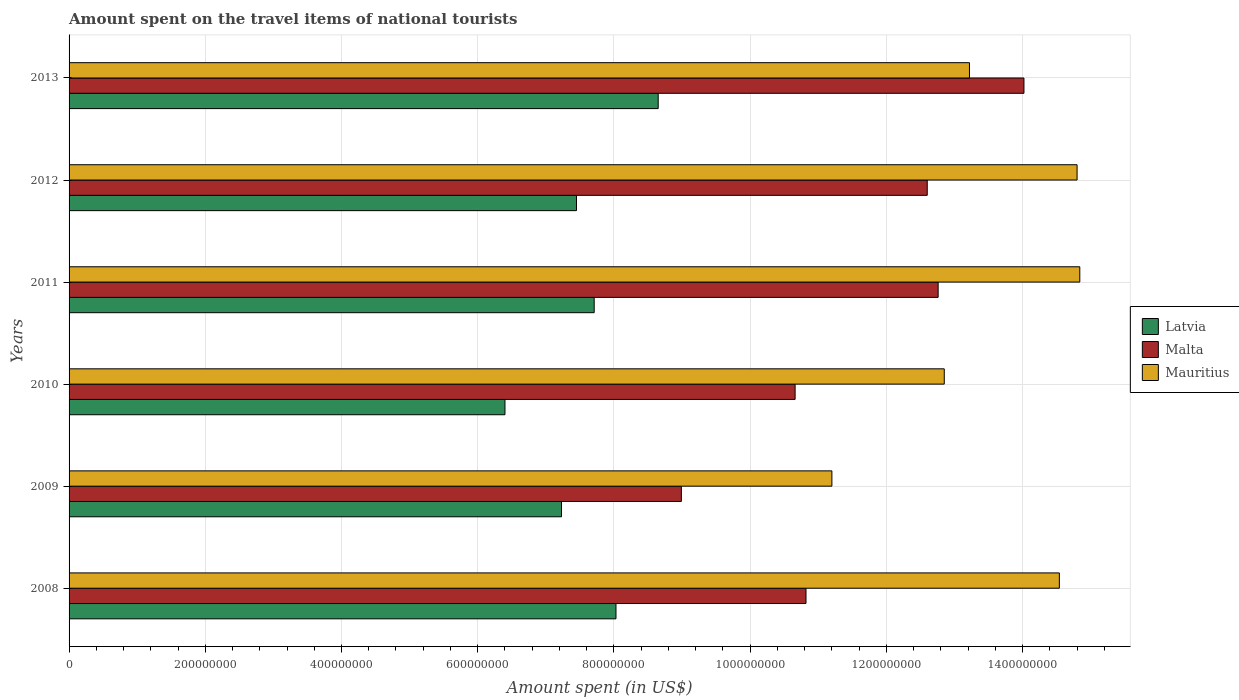How many bars are there on the 2nd tick from the top?
Your response must be concise. 3. What is the label of the 5th group of bars from the top?
Your answer should be very brief. 2009. In how many cases, is the number of bars for a given year not equal to the number of legend labels?
Ensure brevity in your answer.  0. What is the amount spent on the travel items of national tourists in Latvia in 2008?
Your response must be concise. 8.03e+08. Across all years, what is the maximum amount spent on the travel items of national tourists in Malta?
Your answer should be compact. 1.40e+09. Across all years, what is the minimum amount spent on the travel items of national tourists in Malta?
Offer a very short reply. 8.99e+08. In which year was the amount spent on the travel items of national tourists in Latvia maximum?
Your answer should be very brief. 2013. In which year was the amount spent on the travel items of national tourists in Mauritius minimum?
Provide a short and direct response. 2009. What is the total amount spent on the travel items of national tourists in Latvia in the graph?
Offer a very short reply. 4.55e+09. What is the difference between the amount spent on the travel items of national tourists in Malta in 2008 and that in 2009?
Offer a terse response. 1.83e+08. What is the difference between the amount spent on the travel items of national tourists in Latvia in 2009 and the amount spent on the travel items of national tourists in Malta in 2008?
Offer a very short reply. -3.59e+08. What is the average amount spent on the travel items of national tourists in Mauritius per year?
Keep it short and to the point. 1.36e+09. In the year 2010, what is the difference between the amount spent on the travel items of national tourists in Mauritius and amount spent on the travel items of national tourists in Malta?
Keep it short and to the point. 2.19e+08. What is the ratio of the amount spent on the travel items of national tourists in Malta in 2008 to that in 2009?
Your answer should be compact. 1.2. Is the difference between the amount spent on the travel items of national tourists in Mauritius in 2008 and 2009 greater than the difference between the amount spent on the travel items of national tourists in Malta in 2008 and 2009?
Offer a terse response. Yes. What is the difference between the highest and the second highest amount spent on the travel items of national tourists in Malta?
Offer a terse response. 1.26e+08. What is the difference between the highest and the lowest amount spent on the travel items of national tourists in Mauritius?
Keep it short and to the point. 3.64e+08. In how many years, is the amount spent on the travel items of national tourists in Malta greater than the average amount spent on the travel items of national tourists in Malta taken over all years?
Provide a succinct answer. 3. What does the 2nd bar from the top in 2009 represents?
Give a very brief answer. Malta. What does the 3rd bar from the bottom in 2008 represents?
Make the answer very short. Mauritius. Is it the case that in every year, the sum of the amount spent on the travel items of national tourists in Malta and amount spent on the travel items of national tourists in Latvia is greater than the amount spent on the travel items of national tourists in Mauritius?
Give a very brief answer. Yes. How many bars are there?
Provide a succinct answer. 18. Are all the bars in the graph horizontal?
Your answer should be compact. Yes. How many years are there in the graph?
Give a very brief answer. 6. Are the values on the major ticks of X-axis written in scientific E-notation?
Give a very brief answer. No. Where does the legend appear in the graph?
Your response must be concise. Center right. How are the legend labels stacked?
Provide a succinct answer. Vertical. What is the title of the graph?
Your answer should be compact. Amount spent on the travel items of national tourists. What is the label or title of the X-axis?
Offer a terse response. Amount spent (in US$). What is the Amount spent (in US$) of Latvia in 2008?
Provide a succinct answer. 8.03e+08. What is the Amount spent (in US$) of Malta in 2008?
Give a very brief answer. 1.08e+09. What is the Amount spent (in US$) in Mauritius in 2008?
Provide a succinct answer. 1.45e+09. What is the Amount spent (in US$) in Latvia in 2009?
Offer a terse response. 7.23e+08. What is the Amount spent (in US$) of Malta in 2009?
Make the answer very short. 8.99e+08. What is the Amount spent (in US$) of Mauritius in 2009?
Offer a terse response. 1.12e+09. What is the Amount spent (in US$) in Latvia in 2010?
Your answer should be compact. 6.40e+08. What is the Amount spent (in US$) in Malta in 2010?
Your response must be concise. 1.07e+09. What is the Amount spent (in US$) in Mauritius in 2010?
Your response must be concise. 1.28e+09. What is the Amount spent (in US$) of Latvia in 2011?
Ensure brevity in your answer.  7.71e+08. What is the Amount spent (in US$) of Malta in 2011?
Your answer should be very brief. 1.28e+09. What is the Amount spent (in US$) in Mauritius in 2011?
Your response must be concise. 1.48e+09. What is the Amount spent (in US$) of Latvia in 2012?
Offer a terse response. 7.45e+08. What is the Amount spent (in US$) in Malta in 2012?
Offer a very short reply. 1.26e+09. What is the Amount spent (in US$) in Mauritius in 2012?
Provide a succinct answer. 1.48e+09. What is the Amount spent (in US$) of Latvia in 2013?
Provide a succinct answer. 8.65e+08. What is the Amount spent (in US$) of Malta in 2013?
Make the answer very short. 1.40e+09. What is the Amount spent (in US$) of Mauritius in 2013?
Provide a short and direct response. 1.32e+09. Across all years, what is the maximum Amount spent (in US$) in Latvia?
Make the answer very short. 8.65e+08. Across all years, what is the maximum Amount spent (in US$) in Malta?
Offer a very short reply. 1.40e+09. Across all years, what is the maximum Amount spent (in US$) in Mauritius?
Ensure brevity in your answer.  1.48e+09. Across all years, what is the minimum Amount spent (in US$) of Latvia?
Give a very brief answer. 6.40e+08. Across all years, what is the minimum Amount spent (in US$) of Malta?
Your answer should be very brief. 8.99e+08. Across all years, what is the minimum Amount spent (in US$) of Mauritius?
Provide a short and direct response. 1.12e+09. What is the total Amount spent (in US$) of Latvia in the graph?
Offer a terse response. 4.55e+09. What is the total Amount spent (in US$) of Malta in the graph?
Your answer should be compact. 6.98e+09. What is the total Amount spent (in US$) of Mauritius in the graph?
Make the answer very short. 8.14e+09. What is the difference between the Amount spent (in US$) in Latvia in 2008 and that in 2009?
Keep it short and to the point. 8.00e+07. What is the difference between the Amount spent (in US$) of Malta in 2008 and that in 2009?
Your answer should be very brief. 1.83e+08. What is the difference between the Amount spent (in US$) of Mauritius in 2008 and that in 2009?
Give a very brief answer. 3.34e+08. What is the difference between the Amount spent (in US$) in Latvia in 2008 and that in 2010?
Give a very brief answer. 1.63e+08. What is the difference between the Amount spent (in US$) of Malta in 2008 and that in 2010?
Your response must be concise. 1.60e+07. What is the difference between the Amount spent (in US$) of Mauritius in 2008 and that in 2010?
Give a very brief answer. 1.69e+08. What is the difference between the Amount spent (in US$) of Latvia in 2008 and that in 2011?
Ensure brevity in your answer.  3.20e+07. What is the difference between the Amount spent (in US$) of Malta in 2008 and that in 2011?
Your answer should be compact. -1.94e+08. What is the difference between the Amount spent (in US$) of Mauritius in 2008 and that in 2011?
Give a very brief answer. -3.00e+07. What is the difference between the Amount spent (in US$) of Latvia in 2008 and that in 2012?
Provide a succinct answer. 5.80e+07. What is the difference between the Amount spent (in US$) in Malta in 2008 and that in 2012?
Give a very brief answer. -1.78e+08. What is the difference between the Amount spent (in US$) in Mauritius in 2008 and that in 2012?
Your answer should be very brief. -2.60e+07. What is the difference between the Amount spent (in US$) of Latvia in 2008 and that in 2013?
Provide a succinct answer. -6.20e+07. What is the difference between the Amount spent (in US$) in Malta in 2008 and that in 2013?
Ensure brevity in your answer.  -3.20e+08. What is the difference between the Amount spent (in US$) in Mauritius in 2008 and that in 2013?
Provide a short and direct response. 1.32e+08. What is the difference between the Amount spent (in US$) of Latvia in 2009 and that in 2010?
Offer a terse response. 8.30e+07. What is the difference between the Amount spent (in US$) of Malta in 2009 and that in 2010?
Give a very brief answer. -1.67e+08. What is the difference between the Amount spent (in US$) in Mauritius in 2009 and that in 2010?
Make the answer very short. -1.65e+08. What is the difference between the Amount spent (in US$) in Latvia in 2009 and that in 2011?
Keep it short and to the point. -4.80e+07. What is the difference between the Amount spent (in US$) in Malta in 2009 and that in 2011?
Ensure brevity in your answer.  -3.77e+08. What is the difference between the Amount spent (in US$) in Mauritius in 2009 and that in 2011?
Give a very brief answer. -3.64e+08. What is the difference between the Amount spent (in US$) of Latvia in 2009 and that in 2012?
Your response must be concise. -2.20e+07. What is the difference between the Amount spent (in US$) in Malta in 2009 and that in 2012?
Provide a succinct answer. -3.61e+08. What is the difference between the Amount spent (in US$) in Mauritius in 2009 and that in 2012?
Keep it short and to the point. -3.60e+08. What is the difference between the Amount spent (in US$) in Latvia in 2009 and that in 2013?
Keep it short and to the point. -1.42e+08. What is the difference between the Amount spent (in US$) of Malta in 2009 and that in 2013?
Give a very brief answer. -5.03e+08. What is the difference between the Amount spent (in US$) in Mauritius in 2009 and that in 2013?
Ensure brevity in your answer.  -2.02e+08. What is the difference between the Amount spent (in US$) in Latvia in 2010 and that in 2011?
Give a very brief answer. -1.31e+08. What is the difference between the Amount spent (in US$) of Malta in 2010 and that in 2011?
Give a very brief answer. -2.10e+08. What is the difference between the Amount spent (in US$) of Mauritius in 2010 and that in 2011?
Provide a short and direct response. -1.99e+08. What is the difference between the Amount spent (in US$) of Latvia in 2010 and that in 2012?
Offer a terse response. -1.05e+08. What is the difference between the Amount spent (in US$) in Malta in 2010 and that in 2012?
Give a very brief answer. -1.94e+08. What is the difference between the Amount spent (in US$) of Mauritius in 2010 and that in 2012?
Offer a very short reply. -1.95e+08. What is the difference between the Amount spent (in US$) in Latvia in 2010 and that in 2013?
Offer a terse response. -2.25e+08. What is the difference between the Amount spent (in US$) of Malta in 2010 and that in 2013?
Your answer should be very brief. -3.36e+08. What is the difference between the Amount spent (in US$) of Mauritius in 2010 and that in 2013?
Offer a terse response. -3.70e+07. What is the difference between the Amount spent (in US$) in Latvia in 2011 and that in 2012?
Your answer should be compact. 2.60e+07. What is the difference between the Amount spent (in US$) of Malta in 2011 and that in 2012?
Provide a succinct answer. 1.60e+07. What is the difference between the Amount spent (in US$) of Latvia in 2011 and that in 2013?
Keep it short and to the point. -9.40e+07. What is the difference between the Amount spent (in US$) of Malta in 2011 and that in 2013?
Your answer should be very brief. -1.26e+08. What is the difference between the Amount spent (in US$) of Mauritius in 2011 and that in 2013?
Give a very brief answer. 1.62e+08. What is the difference between the Amount spent (in US$) in Latvia in 2012 and that in 2013?
Give a very brief answer. -1.20e+08. What is the difference between the Amount spent (in US$) in Malta in 2012 and that in 2013?
Provide a short and direct response. -1.42e+08. What is the difference between the Amount spent (in US$) in Mauritius in 2012 and that in 2013?
Make the answer very short. 1.58e+08. What is the difference between the Amount spent (in US$) of Latvia in 2008 and the Amount spent (in US$) of Malta in 2009?
Your answer should be very brief. -9.60e+07. What is the difference between the Amount spent (in US$) in Latvia in 2008 and the Amount spent (in US$) in Mauritius in 2009?
Keep it short and to the point. -3.17e+08. What is the difference between the Amount spent (in US$) of Malta in 2008 and the Amount spent (in US$) of Mauritius in 2009?
Offer a terse response. -3.80e+07. What is the difference between the Amount spent (in US$) in Latvia in 2008 and the Amount spent (in US$) in Malta in 2010?
Your answer should be very brief. -2.63e+08. What is the difference between the Amount spent (in US$) of Latvia in 2008 and the Amount spent (in US$) of Mauritius in 2010?
Your response must be concise. -4.82e+08. What is the difference between the Amount spent (in US$) in Malta in 2008 and the Amount spent (in US$) in Mauritius in 2010?
Keep it short and to the point. -2.03e+08. What is the difference between the Amount spent (in US$) of Latvia in 2008 and the Amount spent (in US$) of Malta in 2011?
Make the answer very short. -4.73e+08. What is the difference between the Amount spent (in US$) in Latvia in 2008 and the Amount spent (in US$) in Mauritius in 2011?
Provide a short and direct response. -6.81e+08. What is the difference between the Amount spent (in US$) in Malta in 2008 and the Amount spent (in US$) in Mauritius in 2011?
Ensure brevity in your answer.  -4.02e+08. What is the difference between the Amount spent (in US$) of Latvia in 2008 and the Amount spent (in US$) of Malta in 2012?
Your response must be concise. -4.57e+08. What is the difference between the Amount spent (in US$) of Latvia in 2008 and the Amount spent (in US$) of Mauritius in 2012?
Ensure brevity in your answer.  -6.77e+08. What is the difference between the Amount spent (in US$) of Malta in 2008 and the Amount spent (in US$) of Mauritius in 2012?
Your response must be concise. -3.98e+08. What is the difference between the Amount spent (in US$) of Latvia in 2008 and the Amount spent (in US$) of Malta in 2013?
Your response must be concise. -5.99e+08. What is the difference between the Amount spent (in US$) in Latvia in 2008 and the Amount spent (in US$) in Mauritius in 2013?
Your response must be concise. -5.19e+08. What is the difference between the Amount spent (in US$) in Malta in 2008 and the Amount spent (in US$) in Mauritius in 2013?
Make the answer very short. -2.40e+08. What is the difference between the Amount spent (in US$) in Latvia in 2009 and the Amount spent (in US$) in Malta in 2010?
Your response must be concise. -3.43e+08. What is the difference between the Amount spent (in US$) of Latvia in 2009 and the Amount spent (in US$) of Mauritius in 2010?
Make the answer very short. -5.62e+08. What is the difference between the Amount spent (in US$) of Malta in 2009 and the Amount spent (in US$) of Mauritius in 2010?
Offer a terse response. -3.86e+08. What is the difference between the Amount spent (in US$) in Latvia in 2009 and the Amount spent (in US$) in Malta in 2011?
Your response must be concise. -5.53e+08. What is the difference between the Amount spent (in US$) in Latvia in 2009 and the Amount spent (in US$) in Mauritius in 2011?
Provide a short and direct response. -7.61e+08. What is the difference between the Amount spent (in US$) of Malta in 2009 and the Amount spent (in US$) of Mauritius in 2011?
Offer a very short reply. -5.85e+08. What is the difference between the Amount spent (in US$) in Latvia in 2009 and the Amount spent (in US$) in Malta in 2012?
Offer a very short reply. -5.37e+08. What is the difference between the Amount spent (in US$) in Latvia in 2009 and the Amount spent (in US$) in Mauritius in 2012?
Ensure brevity in your answer.  -7.57e+08. What is the difference between the Amount spent (in US$) in Malta in 2009 and the Amount spent (in US$) in Mauritius in 2012?
Provide a succinct answer. -5.81e+08. What is the difference between the Amount spent (in US$) of Latvia in 2009 and the Amount spent (in US$) of Malta in 2013?
Provide a succinct answer. -6.79e+08. What is the difference between the Amount spent (in US$) in Latvia in 2009 and the Amount spent (in US$) in Mauritius in 2013?
Your response must be concise. -5.99e+08. What is the difference between the Amount spent (in US$) of Malta in 2009 and the Amount spent (in US$) of Mauritius in 2013?
Ensure brevity in your answer.  -4.23e+08. What is the difference between the Amount spent (in US$) of Latvia in 2010 and the Amount spent (in US$) of Malta in 2011?
Your answer should be very brief. -6.36e+08. What is the difference between the Amount spent (in US$) of Latvia in 2010 and the Amount spent (in US$) of Mauritius in 2011?
Keep it short and to the point. -8.44e+08. What is the difference between the Amount spent (in US$) in Malta in 2010 and the Amount spent (in US$) in Mauritius in 2011?
Ensure brevity in your answer.  -4.18e+08. What is the difference between the Amount spent (in US$) of Latvia in 2010 and the Amount spent (in US$) of Malta in 2012?
Keep it short and to the point. -6.20e+08. What is the difference between the Amount spent (in US$) of Latvia in 2010 and the Amount spent (in US$) of Mauritius in 2012?
Your response must be concise. -8.40e+08. What is the difference between the Amount spent (in US$) of Malta in 2010 and the Amount spent (in US$) of Mauritius in 2012?
Give a very brief answer. -4.14e+08. What is the difference between the Amount spent (in US$) in Latvia in 2010 and the Amount spent (in US$) in Malta in 2013?
Offer a very short reply. -7.62e+08. What is the difference between the Amount spent (in US$) in Latvia in 2010 and the Amount spent (in US$) in Mauritius in 2013?
Your answer should be compact. -6.82e+08. What is the difference between the Amount spent (in US$) of Malta in 2010 and the Amount spent (in US$) of Mauritius in 2013?
Provide a succinct answer. -2.56e+08. What is the difference between the Amount spent (in US$) in Latvia in 2011 and the Amount spent (in US$) in Malta in 2012?
Provide a succinct answer. -4.89e+08. What is the difference between the Amount spent (in US$) in Latvia in 2011 and the Amount spent (in US$) in Mauritius in 2012?
Provide a succinct answer. -7.09e+08. What is the difference between the Amount spent (in US$) in Malta in 2011 and the Amount spent (in US$) in Mauritius in 2012?
Make the answer very short. -2.04e+08. What is the difference between the Amount spent (in US$) in Latvia in 2011 and the Amount spent (in US$) in Malta in 2013?
Your response must be concise. -6.31e+08. What is the difference between the Amount spent (in US$) in Latvia in 2011 and the Amount spent (in US$) in Mauritius in 2013?
Give a very brief answer. -5.51e+08. What is the difference between the Amount spent (in US$) in Malta in 2011 and the Amount spent (in US$) in Mauritius in 2013?
Make the answer very short. -4.60e+07. What is the difference between the Amount spent (in US$) in Latvia in 2012 and the Amount spent (in US$) in Malta in 2013?
Offer a terse response. -6.57e+08. What is the difference between the Amount spent (in US$) of Latvia in 2012 and the Amount spent (in US$) of Mauritius in 2013?
Provide a short and direct response. -5.77e+08. What is the difference between the Amount spent (in US$) in Malta in 2012 and the Amount spent (in US$) in Mauritius in 2013?
Keep it short and to the point. -6.20e+07. What is the average Amount spent (in US$) in Latvia per year?
Your response must be concise. 7.58e+08. What is the average Amount spent (in US$) of Malta per year?
Your response must be concise. 1.16e+09. What is the average Amount spent (in US$) of Mauritius per year?
Make the answer very short. 1.36e+09. In the year 2008, what is the difference between the Amount spent (in US$) of Latvia and Amount spent (in US$) of Malta?
Keep it short and to the point. -2.79e+08. In the year 2008, what is the difference between the Amount spent (in US$) of Latvia and Amount spent (in US$) of Mauritius?
Give a very brief answer. -6.51e+08. In the year 2008, what is the difference between the Amount spent (in US$) of Malta and Amount spent (in US$) of Mauritius?
Offer a very short reply. -3.72e+08. In the year 2009, what is the difference between the Amount spent (in US$) in Latvia and Amount spent (in US$) in Malta?
Your answer should be very brief. -1.76e+08. In the year 2009, what is the difference between the Amount spent (in US$) of Latvia and Amount spent (in US$) of Mauritius?
Give a very brief answer. -3.97e+08. In the year 2009, what is the difference between the Amount spent (in US$) in Malta and Amount spent (in US$) in Mauritius?
Keep it short and to the point. -2.21e+08. In the year 2010, what is the difference between the Amount spent (in US$) of Latvia and Amount spent (in US$) of Malta?
Keep it short and to the point. -4.26e+08. In the year 2010, what is the difference between the Amount spent (in US$) of Latvia and Amount spent (in US$) of Mauritius?
Ensure brevity in your answer.  -6.45e+08. In the year 2010, what is the difference between the Amount spent (in US$) in Malta and Amount spent (in US$) in Mauritius?
Your response must be concise. -2.19e+08. In the year 2011, what is the difference between the Amount spent (in US$) of Latvia and Amount spent (in US$) of Malta?
Keep it short and to the point. -5.05e+08. In the year 2011, what is the difference between the Amount spent (in US$) of Latvia and Amount spent (in US$) of Mauritius?
Give a very brief answer. -7.13e+08. In the year 2011, what is the difference between the Amount spent (in US$) of Malta and Amount spent (in US$) of Mauritius?
Your answer should be very brief. -2.08e+08. In the year 2012, what is the difference between the Amount spent (in US$) in Latvia and Amount spent (in US$) in Malta?
Make the answer very short. -5.15e+08. In the year 2012, what is the difference between the Amount spent (in US$) in Latvia and Amount spent (in US$) in Mauritius?
Provide a short and direct response. -7.35e+08. In the year 2012, what is the difference between the Amount spent (in US$) of Malta and Amount spent (in US$) of Mauritius?
Ensure brevity in your answer.  -2.20e+08. In the year 2013, what is the difference between the Amount spent (in US$) in Latvia and Amount spent (in US$) in Malta?
Provide a succinct answer. -5.37e+08. In the year 2013, what is the difference between the Amount spent (in US$) of Latvia and Amount spent (in US$) of Mauritius?
Provide a succinct answer. -4.57e+08. In the year 2013, what is the difference between the Amount spent (in US$) in Malta and Amount spent (in US$) in Mauritius?
Offer a very short reply. 8.00e+07. What is the ratio of the Amount spent (in US$) in Latvia in 2008 to that in 2009?
Your answer should be compact. 1.11. What is the ratio of the Amount spent (in US$) of Malta in 2008 to that in 2009?
Your answer should be compact. 1.2. What is the ratio of the Amount spent (in US$) of Mauritius in 2008 to that in 2009?
Offer a terse response. 1.3. What is the ratio of the Amount spent (in US$) of Latvia in 2008 to that in 2010?
Give a very brief answer. 1.25. What is the ratio of the Amount spent (in US$) in Malta in 2008 to that in 2010?
Provide a short and direct response. 1.01. What is the ratio of the Amount spent (in US$) in Mauritius in 2008 to that in 2010?
Make the answer very short. 1.13. What is the ratio of the Amount spent (in US$) of Latvia in 2008 to that in 2011?
Offer a terse response. 1.04. What is the ratio of the Amount spent (in US$) in Malta in 2008 to that in 2011?
Ensure brevity in your answer.  0.85. What is the ratio of the Amount spent (in US$) in Mauritius in 2008 to that in 2011?
Offer a very short reply. 0.98. What is the ratio of the Amount spent (in US$) of Latvia in 2008 to that in 2012?
Make the answer very short. 1.08. What is the ratio of the Amount spent (in US$) of Malta in 2008 to that in 2012?
Provide a short and direct response. 0.86. What is the ratio of the Amount spent (in US$) of Mauritius in 2008 to that in 2012?
Make the answer very short. 0.98. What is the ratio of the Amount spent (in US$) in Latvia in 2008 to that in 2013?
Make the answer very short. 0.93. What is the ratio of the Amount spent (in US$) in Malta in 2008 to that in 2013?
Offer a very short reply. 0.77. What is the ratio of the Amount spent (in US$) in Mauritius in 2008 to that in 2013?
Offer a very short reply. 1.1. What is the ratio of the Amount spent (in US$) in Latvia in 2009 to that in 2010?
Offer a terse response. 1.13. What is the ratio of the Amount spent (in US$) of Malta in 2009 to that in 2010?
Keep it short and to the point. 0.84. What is the ratio of the Amount spent (in US$) of Mauritius in 2009 to that in 2010?
Give a very brief answer. 0.87. What is the ratio of the Amount spent (in US$) in Latvia in 2009 to that in 2011?
Your response must be concise. 0.94. What is the ratio of the Amount spent (in US$) in Malta in 2009 to that in 2011?
Give a very brief answer. 0.7. What is the ratio of the Amount spent (in US$) in Mauritius in 2009 to that in 2011?
Keep it short and to the point. 0.75. What is the ratio of the Amount spent (in US$) in Latvia in 2009 to that in 2012?
Your response must be concise. 0.97. What is the ratio of the Amount spent (in US$) of Malta in 2009 to that in 2012?
Offer a terse response. 0.71. What is the ratio of the Amount spent (in US$) in Mauritius in 2009 to that in 2012?
Your answer should be compact. 0.76. What is the ratio of the Amount spent (in US$) of Latvia in 2009 to that in 2013?
Provide a short and direct response. 0.84. What is the ratio of the Amount spent (in US$) of Malta in 2009 to that in 2013?
Provide a succinct answer. 0.64. What is the ratio of the Amount spent (in US$) of Mauritius in 2009 to that in 2013?
Provide a short and direct response. 0.85. What is the ratio of the Amount spent (in US$) in Latvia in 2010 to that in 2011?
Your answer should be compact. 0.83. What is the ratio of the Amount spent (in US$) of Malta in 2010 to that in 2011?
Ensure brevity in your answer.  0.84. What is the ratio of the Amount spent (in US$) in Mauritius in 2010 to that in 2011?
Your answer should be compact. 0.87. What is the ratio of the Amount spent (in US$) of Latvia in 2010 to that in 2012?
Offer a very short reply. 0.86. What is the ratio of the Amount spent (in US$) of Malta in 2010 to that in 2012?
Ensure brevity in your answer.  0.85. What is the ratio of the Amount spent (in US$) of Mauritius in 2010 to that in 2012?
Give a very brief answer. 0.87. What is the ratio of the Amount spent (in US$) in Latvia in 2010 to that in 2013?
Keep it short and to the point. 0.74. What is the ratio of the Amount spent (in US$) of Malta in 2010 to that in 2013?
Your response must be concise. 0.76. What is the ratio of the Amount spent (in US$) in Latvia in 2011 to that in 2012?
Offer a terse response. 1.03. What is the ratio of the Amount spent (in US$) of Malta in 2011 to that in 2012?
Your answer should be very brief. 1.01. What is the ratio of the Amount spent (in US$) in Latvia in 2011 to that in 2013?
Provide a short and direct response. 0.89. What is the ratio of the Amount spent (in US$) of Malta in 2011 to that in 2013?
Your response must be concise. 0.91. What is the ratio of the Amount spent (in US$) in Mauritius in 2011 to that in 2013?
Offer a terse response. 1.12. What is the ratio of the Amount spent (in US$) of Latvia in 2012 to that in 2013?
Your answer should be compact. 0.86. What is the ratio of the Amount spent (in US$) of Malta in 2012 to that in 2013?
Offer a very short reply. 0.9. What is the ratio of the Amount spent (in US$) of Mauritius in 2012 to that in 2013?
Give a very brief answer. 1.12. What is the difference between the highest and the second highest Amount spent (in US$) in Latvia?
Give a very brief answer. 6.20e+07. What is the difference between the highest and the second highest Amount spent (in US$) in Malta?
Ensure brevity in your answer.  1.26e+08. What is the difference between the highest and the lowest Amount spent (in US$) of Latvia?
Offer a terse response. 2.25e+08. What is the difference between the highest and the lowest Amount spent (in US$) in Malta?
Offer a terse response. 5.03e+08. What is the difference between the highest and the lowest Amount spent (in US$) of Mauritius?
Provide a succinct answer. 3.64e+08. 